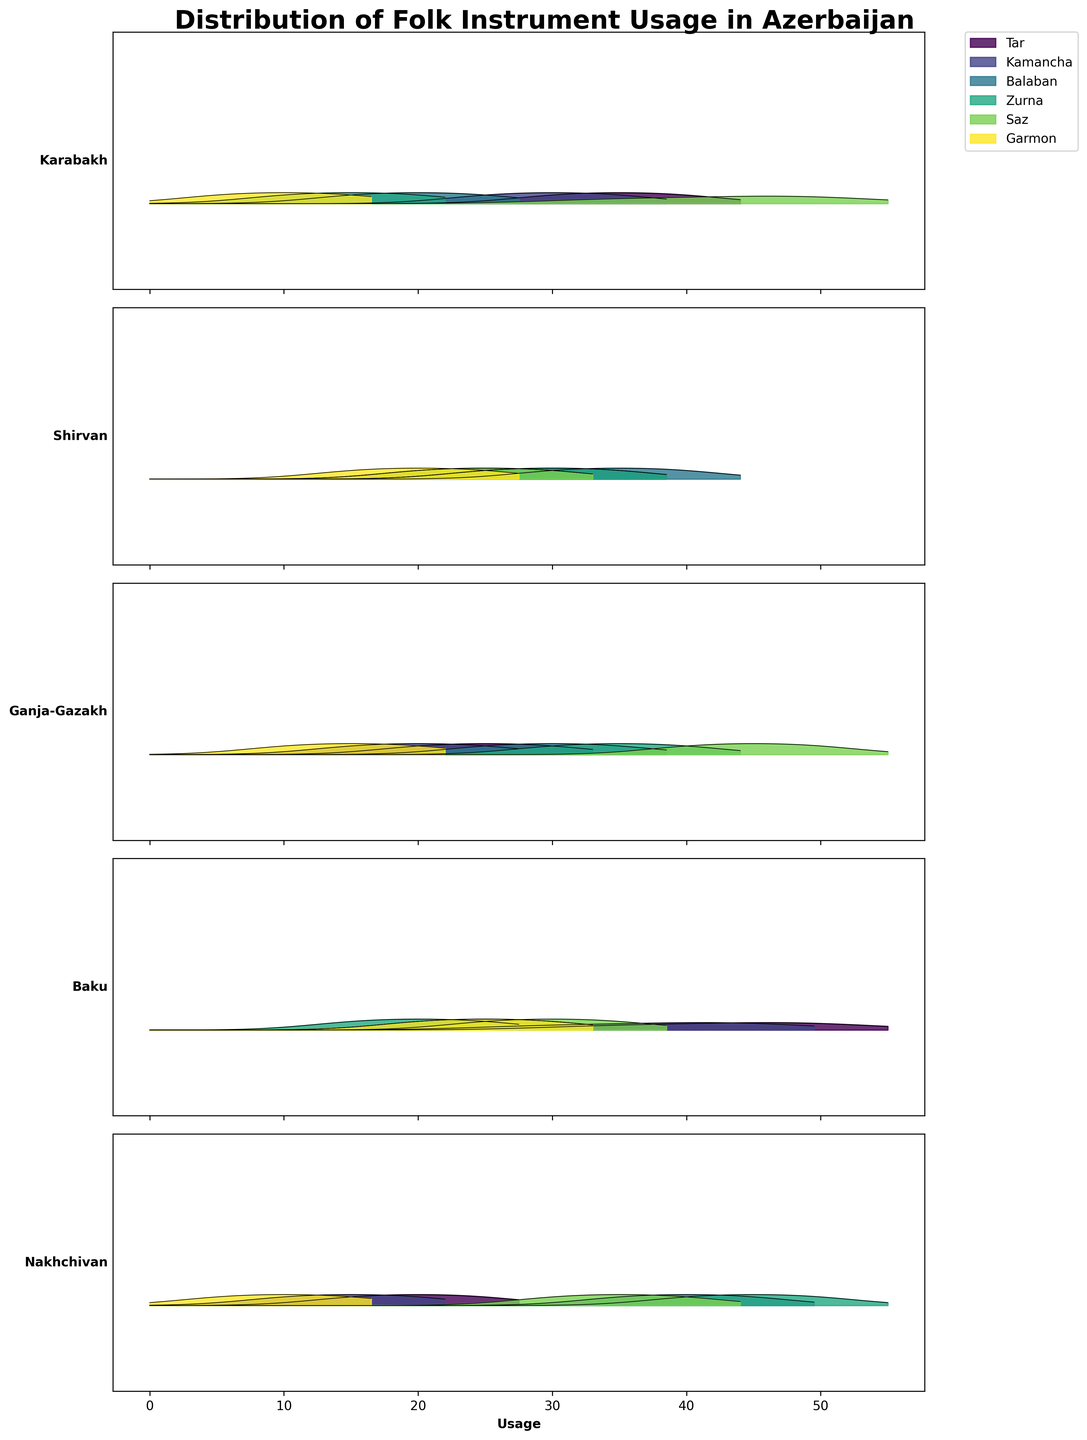Which region has the highest usage of the Tar in the year 2000? Look at the ridgelines, locate the year 2000 for each region, and observe the peak values for the Tar instrument. Baku shows the highest peak in 2000 for the Tar.
Answer: Baku Which instrument shows the most increased usage in Ganja-Gazakh from 1920 to 2000? Compare the peaks of each instrument's ridgeline from 1920 and 2000 in the Ganja-Gazakh region. The Saz shows the highest increase in peak value between these years.
Answer: Saz What is the average usage of the Kamancha across all regions in 1960? Observe the ridgelines for Kamancha in the year 1960 across all regions, then calculate the average of their peaks: (30+25+20+40+15)/5 = 26
Answer: 26 Which instrument had the highest peak usage in Nakhchivan in 1920? Identify the instrument with the highest peak on the ridgeline for Nakhchivan in 1920. The Zurna has the highest peak.
Answer: Zurna What is the general trend of Tar usage in Karabakh from 1920 to 2000? Track the peaks of the ridgeline for the Tar instrument in Karabakh across 1920, 1960, and 2000. The Tar usage increased from 1920 to 1960 but then slightly decreased in 2000.
Answer: Increased and then slightly decreased Which instrument has the smallest difference in usage between Shirvan and Baku in 2000? For the year 2000, compare the peaks of each instrument between Shirvan and Baku. The Tar shows the smallest difference in their peaks.
Answer: Tar Which region shows the highest overall variation in instrument usage from 1920 to 2000? Observe the overall spread and changes in the ridgelines for each region across all instruments from 1920 to 2000. Nakhchivan shows the highest variation due to significant changes in multiple instruments.
Answer: Nakhchivan 